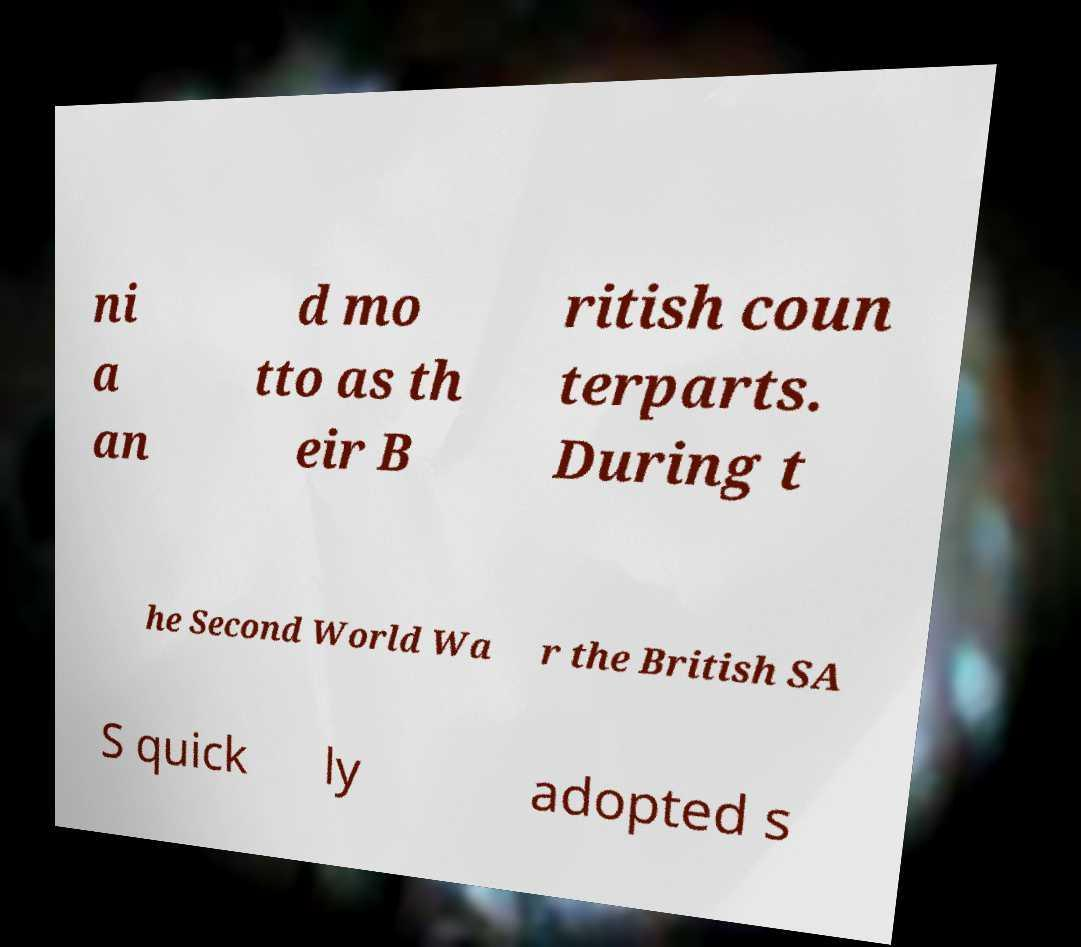Please read and relay the text visible in this image. What does it say? ni a an d mo tto as th eir B ritish coun terparts. During t he Second World Wa r the British SA S quick ly adopted s 